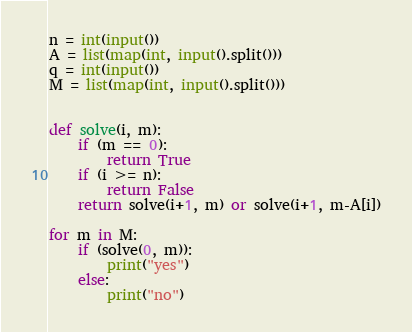<code> <loc_0><loc_0><loc_500><loc_500><_Python_>n = int(input())
A = list(map(int, input().split()))
q = int(input())
M = list(map(int, input().split()))


def solve(i, m):
    if (m == 0):
        return True
    if (i >= n):
        return False
    return solve(i+1, m) or solve(i+1, m-A[i])

for m in M:
    if (solve(0, m)):
        print("yes")
    else:
        print("no")</code> 